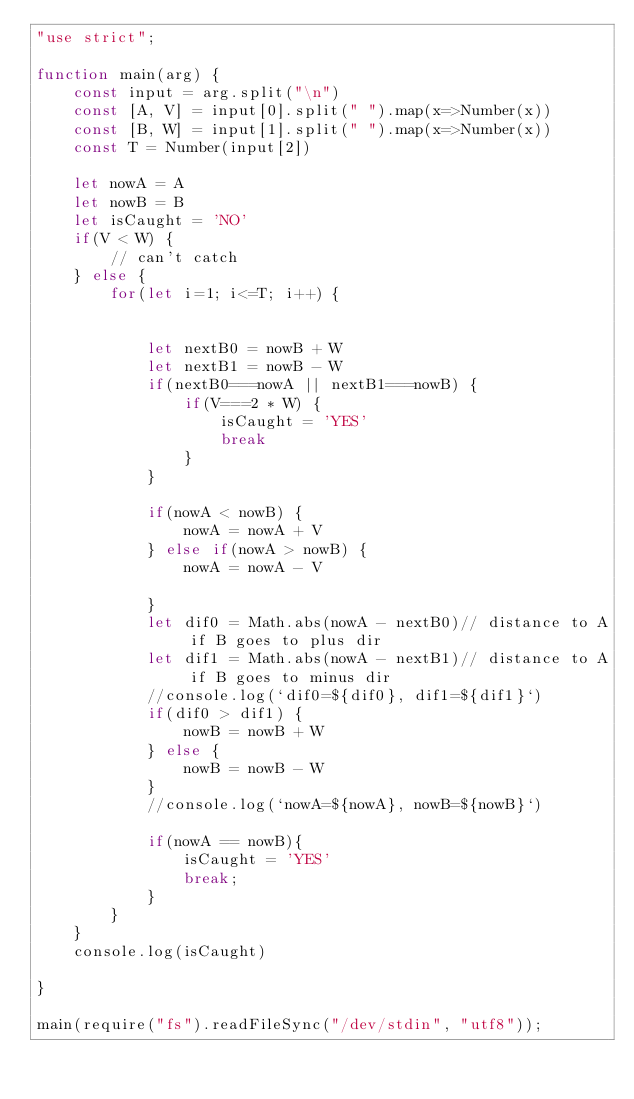<code> <loc_0><loc_0><loc_500><loc_500><_JavaScript_>"use strict";

function main(arg) {
    const input = arg.split("\n")
    const [A, V] = input[0].split(" ").map(x=>Number(x))
    const [B, W] = input[1].split(" ").map(x=>Number(x))
    const T = Number(input[2])

    let nowA = A
    let nowB = B
    let isCaught = 'NO'
    if(V < W) {
        // can't catch
    } else {
        for(let i=1; i<=T; i++) {
            
            
            let nextB0 = nowB + W
            let nextB1 = nowB - W
            if(nextB0===nowA || nextB1===nowB) {
                if(V===2 * W) {
                    isCaught = 'YES'
                    break
                }
            }
            
            if(nowA < nowB) {
                nowA = nowA + V
            } else if(nowA > nowB) {
                nowA = nowA - V
                
            }
            let dif0 = Math.abs(nowA - nextB0)// distance to A if B goes to plus dir
            let dif1 = Math.abs(nowA - nextB1)// distance to A if B goes to minus dir
            //console.log(`dif0=${dif0}, dif1=${dif1}`)
            if(dif0 > dif1) {
                nowB = nowB + W
            } else {
                nowB = nowB - W
            }
            //console.log(`nowA=${nowA}, nowB=${nowB}`)
            
            if(nowA == nowB){
                isCaught = 'YES'
                break;
            }
        }
    }
    console.log(isCaught)
    
}

main(require("fs").readFileSync("/dev/stdin", "utf8"));</code> 